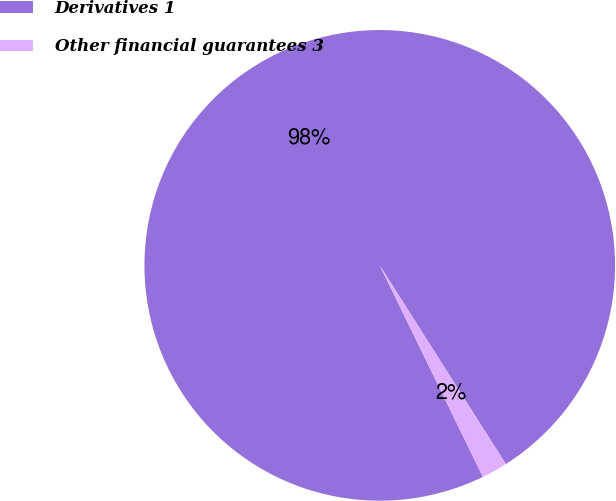Convert chart. <chart><loc_0><loc_0><loc_500><loc_500><pie_chart><fcel>Derivatives 1<fcel>Other financial guarantees 3<nl><fcel>98.22%<fcel>1.78%<nl></chart> 